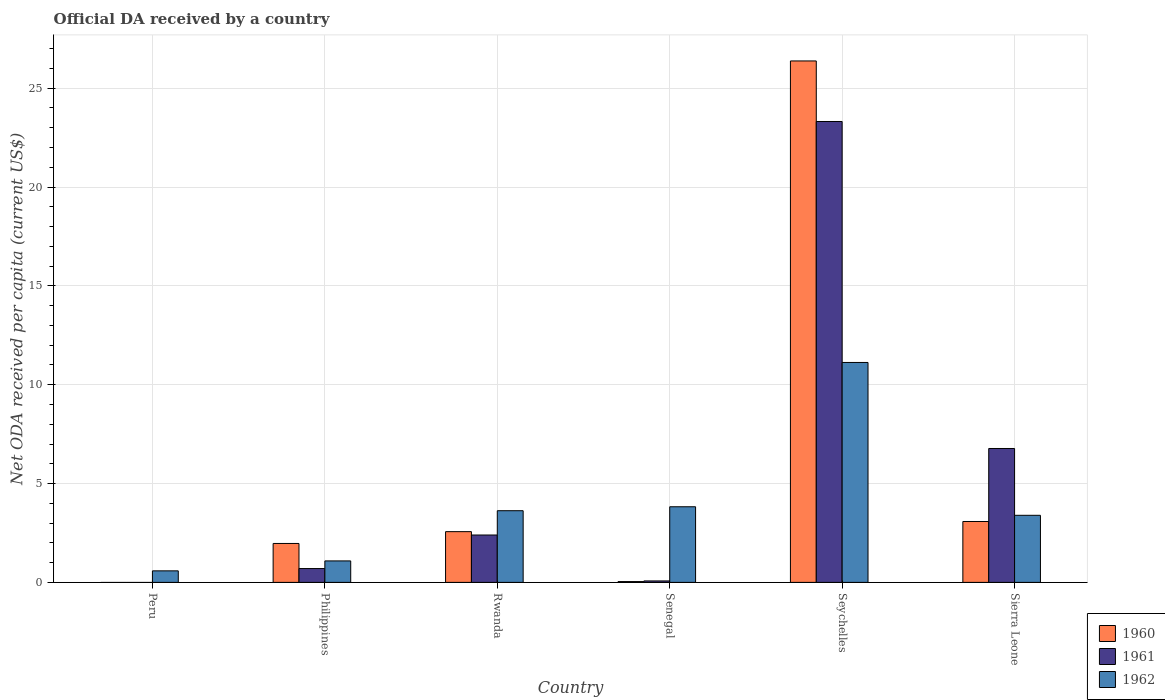Are the number of bars per tick equal to the number of legend labels?
Make the answer very short. No. In how many cases, is the number of bars for a given country not equal to the number of legend labels?
Provide a short and direct response. 1. What is the ODA received in in 1962 in Seychelles?
Your answer should be very brief. 11.13. Across all countries, what is the maximum ODA received in in 1961?
Keep it short and to the point. 23.32. Across all countries, what is the minimum ODA received in in 1960?
Provide a succinct answer. 0. In which country was the ODA received in in 1961 maximum?
Provide a succinct answer. Seychelles. What is the total ODA received in in 1961 in the graph?
Offer a very short reply. 33.26. What is the difference between the ODA received in in 1962 in Peru and that in Philippines?
Offer a very short reply. -0.5. What is the difference between the ODA received in in 1962 in Peru and the ODA received in in 1960 in Seychelles?
Your response must be concise. -25.8. What is the average ODA received in in 1960 per country?
Your answer should be compact. 5.67. What is the difference between the ODA received in of/in 1960 and ODA received in of/in 1962 in Sierra Leone?
Ensure brevity in your answer.  -0.31. What is the ratio of the ODA received in in 1962 in Seychelles to that in Sierra Leone?
Provide a succinct answer. 3.28. Is the ODA received in in 1962 in Philippines less than that in Seychelles?
Your answer should be compact. Yes. What is the difference between the highest and the second highest ODA received in in 1960?
Offer a very short reply. 23.3. What is the difference between the highest and the lowest ODA received in in 1962?
Provide a succinct answer. 10.54. Is the sum of the ODA received in in 1960 in Rwanda and Senegal greater than the maximum ODA received in in 1962 across all countries?
Your answer should be compact. No. How many countries are there in the graph?
Your answer should be very brief. 6. Are the values on the major ticks of Y-axis written in scientific E-notation?
Keep it short and to the point. No. Does the graph contain any zero values?
Offer a very short reply. Yes. What is the title of the graph?
Offer a terse response. Official DA received by a country. What is the label or title of the Y-axis?
Provide a short and direct response. Net ODA received per capita (current US$). What is the Net ODA received per capita (current US$) of 1962 in Peru?
Make the answer very short. 0.58. What is the Net ODA received per capita (current US$) of 1960 in Philippines?
Your answer should be compact. 1.97. What is the Net ODA received per capita (current US$) of 1961 in Philippines?
Offer a very short reply. 0.7. What is the Net ODA received per capita (current US$) in 1962 in Philippines?
Offer a terse response. 1.09. What is the Net ODA received per capita (current US$) of 1960 in Rwanda?
Ensure brevity in your answer.  2.57. What is the Net ODA received per capita (current US$) in 1961 in Rwanda?
Make the answer very short. 2.4. What is the Net ODA received per capita (current US$) of 1962 in Rwanda?
Your response must be concise. 3.63. What is the Net ODA received per capita (current US$) in 1960 in Senegal?
Ensure brevity in your answer.  0.04. What is the Net ODA received per capita (current US$) of 1961 in Senegal?
Your answer should be very brief. 0.07. What is the Net ODA received per capita (current US$) of 1962 in Senegal?
Your response must be concise. 3.83. What is the Net ODA received per capita (current US$) in 1960 in Seychelles?
Your response must be concise. 26.38. What is the Net ODA received per capita (current US$) in 1961 in Seychelles?
Your answer should be very brief. 23.32. What is the Net ODA received per capita (current US$) in 1962 in Seychelles?
Provide a succinct answer. 11.13. What is the Net ODA received per capita (current US$) of 1960 in Sierra Leone?
Your response must be concise. 3.08. What is the Net ODA received per capita (current US$) of 1961 in Sierra Leone?
Give a very brief answer. 6.77. What is the Net ODA received per capita (current US$) in 1962 in Sierra Leone?
Offer a terse response. 3.39. Across all countries, what is the maximum Net ODA received per capita (current US$) in 1960?
Offer a terse response. 26.38. Across all countries, what is the maximum Net ODA received per capita (current US$) in 1961?
Give a very brief answer. 23.32. Across all countries, what is the maximum Net ODA received per capita (current US$) in 1962?
Ensure brevity in your answer.  11.13. Across all countries, what is the minimum Net ODA received per capita (current US$) in 1960?
Your answer should be very brief. 0. Across all countries, what is the minimum Net ODA received per capita (current US$) in 1961?
Give a very brief answer. 0. Across all countries, what is the minimum Net ODA received per capita (current US$) of 1962?
Give a very brief answer. 0.58. What is the total Net ODA received per capita (current US$) of 1960 in the graph?
Offer a terse response. 34.04. What is the total Net ODA received per capita (current US$) in 1961 in the graph?
Offer a terse response. 33.26. What is the total Net ODA received per capita (current US$) of 1962 in the graph?
Ensure brevity in your answer.  23.64. What is the difference between the Net ODA received per capita (current US$) in 1962 in Peru and that in Philippines?
Offer a very short reply. -0.5. What is the difference between the Net ODA received per capita (current US$) in 1962 in Peru and that in Rwanda?
Make the answer very short. -3.04. What is the difference between the Net ODA received per capita (current US$) in 1962 in Peru and that in Senegal?
Make the answer very short. -3.24. What is the difference between the Net ODA received per capita (current US$) of 1962 in Peru and that in Seychelles?
Give a very brief answer. -10.54. What is the difference between the Net ODA received per capita (current US$) in 1962 in Peru and that in Sierra Leone?
Provide a succinct answer. -2.81. What is the difference between the Net ODA received per capita (current US$) of 1960 in Philippines and that in Rwanda?
Make the answer very short. -0.6. What is the difference between the Net ODA received per capita (current US$) of 1961 in Philippines and that in Rwanda?
Give a very brief answer. -1.7. What is the difference between the Net ODA received per capita (current US$) of 1962 in Philippines and that in Rwanda?
Ensure brevity in your answer.  -2.54. What is the difference between the Net ODA received per capita (current US$) in 1960 in Philippines and that in Senegal?
Your response must be concise. 1.93. What is the difference between the Net ODA received per capita (current US$) of 1961 in Philippines and that in Senegal?
Offer a very short reply. 0.63. What is the difference between the Net ODA received per capita (current US$) of 1962 in Philippines and that in Senegal?
Keep it short and to the point. -2.74. What is the difference between the Net ODA received per capita (current US$) in 1960 in Philippines and that in Seychelles?
Provide a short and direct response. -24.41. What is the difference between the Net ODA received per capita (current US$) of 1961 in Philippines and that in Seychelles?
Provide a short and direct response. -22.62. What is the difference between the Net ODA received per capita (current US$) of 1962 in Philippines and that in Seychelles?
Offer a terse response. -10.04. What is the difference between the Net ODA received per capita (current US$) of 1960 in Philippines and that in Sierra Leone?
Provide a succinct answer. -1.11. What is the difference between the Net ODA received per capita (current US$) of 1961 in Philippines and that in Sierra Leone?
Provide a succinct answer. -6.07. What is the difference between the Net ODA received per capita (current US$) in 1962 in Philippines and that in Sierra Leone?
Give a very brief answer. -2.31. What is the difference between the Net ODA received per capita (current US$) of 1960 in Rwanda and that in Senegal?
Make the answer very short. 2.53. What is the difference between the Net ODA received per capita (current US$) in 1961 in Rwanda and that in Senegal?
Ensure brevity in your answer.  2.32. What is the difference between the Net ODA received per capita (current US$) of 1960 in Rwanda and that in Seychelles?
Provide a short and direct response. -23.81. What is the difference between the Net ODA received per capita (current US$) of 1961 in Rwanda and that in Seychelles?
Your answer should be compact. -20.92. What is the difference between the Net ODA received per capita (current US$) of 1962 in Rwanda and that in Seychelles?
Give a very brief answer. -7.5. What is the difference between the Net ODA received per capita (current US$) in 1960 in Rwanda and that in Sierra Leone?
Provide a succinct answer. -0.51. What is the difference between the Net ODA received per capita (current US$) of 1961 in Rwanda and that in Sierra Leone?
Ensure brevity in your answer.  -4.38. What is the difference between the Net ODA received per capita (current US$) of 1962 in Rwanda and that in Sierra Leone?
Provide a short and direct response. 0.23. What is the difference between the Net ODA received per capita (current US$) of 1960 in Senegal and that in Seychelles?
Your answer should be compact. -26.34. What is the difference between the Net ODA received per capita (current US$) in 1961 in Senegal and that in Seychelles?
Provide a succinct answer. -23.24. What is the difference between the Net ODA received per capita (current US$) of 1962 in Senegal and that in Seychelles?
Your answer should be very brief. -7.3. What is the difference between the Net ODA received per capita (current US$) of 1960 in Senegal and that in Sierra Leone?
Offer a very short reply. -3.04. What is the difference between the Net ODA received per capita (current US$) of 1961 in Senegal and that in Sierra Leone?
Provide a succinct answer. -6.7. What is the difference between the Net ODA received per capita (current US$) in 1962 in Senegal and that in Sierra Leone?
Offer a very short reply. 0.43. What is the difference between the Net ODA received per capita (current US$) of 1960 in Seychelles and that in Sierra Leone?
Your answer should be very brief. 23.3. What is the difference between the Net ODA received per capita (current US$) in 1961 in Seychelles and that in Sierra Leone?
Make the answer very short. 16.54. What is the difference between the Net ODA received per capita (current US$) of 1962 in Seychelles and that in Sierra Leone?
Provide a succinct answer. 7.73. What is the difference between the Net ODA received per capita (current US$) of 1960 in Philippines and the Net ODA received per capita (current US$) of 1961 in Rwanda?
Offer a very short reply. -0.43. What is the difference between the Net ODA received per capita (current US$) of 1960 in Philippines and the Net ODA received per capita (current US$) of 1962 in Rwanda?
Ensure brevity in your answer.  -1.66. What is the difference between the Net ODA received per capita (current US$) of 1961 in Philippines and the Net ODA received per capita (current US$) of 1962 in Rwanda?
Ensure brevity in your answer.  -2.93. What is the difference between the Net ODA received per capita (current US$) in 1960 in Philippines and the Net ODA received per capita (current US$) in 1961 in Senegal?
Provide a succinct answer. 1.9. What is the difference between the Net ODA received per capita (current US$) of 1960 in Philippines and the Net ODA received per capita (current US$) of 1962 in Senegal?
Your answer should be very brief. -1.86. What is the difference between the Net ODA received per capita (current US$) in 1961 in Philippines and the Net ODA received per capita (current US$) in 1962 in Senegal?
Ensure brevity in your answer.  -3.13. What is the difference between the Net ODA received per capita (current US$) of 1960 in Philippines and the Net ODA received per capita (current US$) of 1961 in Seychelles?
Make the answer very short. -21.35. What is the difference between the Net ODA received per capita (current US$) in 1960 in Philippines and the Net ODA received per capita (current US$) in 1962 in Seychelles?
Keep it short and to the point. -9.16. What is the difference between the Net ODA received per capita (current US$) in 1961 in Philippines and the Net ODA received per capita (current US$) in 1962 in Seychelles?
Offer a terse response. -10.43. What is the difference between the Net ODA received per capita (current US$) in 1960 in Philippines and the Net ODA received per capita (current US$) in 1961 in Sierra Leone?
Offer a very short reply. -4.8. What is the difference between the Net ODA received per capita (current US$) in 1960 in Philippines and the Net ODA received per capita (current US$) in 1962 in Sierra Leone?
Your answer should be very brief. -1.42. What is the difference between the Net ODA received per capita (current US$) of 1961 in Philippines and the Net ODA received per capita (current US$) of 1962 in Sierra Leone?
Offer a very short reply. -2.69. What is the difference between the Net ODA received per capita (current US$) of 1960 in Rwanda and the Net ODA received per capita (current US$) of 1961 in Senegal?
Offer a terse response. 2.49. What is the difference between the Net ODA received per capita (current US$) in 1960 in Rwanda and the Net ODA received per capita (current US$) in 1962 in Senegal?
Offer a very short reply. -1.26. What is the difference between the Net ODA received per capita (current US$) in 1961 in Rwanda and the Net ODA received per capita (current US$) in 1962 in Senegal?
Provide a succinct answer. -1.43. What is the difference between the Net ODA received per capita (current US$) of 1960 in Rwanda and the Net ODA received per capita (current US$) of 1961 in Seychelles?
Ensure brevity in your answer.  -20.75. What is the difference between the Net ODA received per capita (current US$) in 1960 in Rwanda and the Net ODA received per capita (current US$) in 1962 in Seychelles?
Offer a terse response. -8.56. What is the difference between the Net ODA received per capita (current US$) of 1961 in Rwanda and the Net ODA received per capita (current US$) of 1962 in Seychelles?
Your answer should be very brief. -8.73. What is the difference between the Net ODA received per capita (current US$) of 1960 in Rwanda and the Net ODA received per capita (current US$) of 1961 in Sierra Leone?
Keep it short and to the point. -4.21. What is the difference between the Net ODA received per capita (current US$) of 1960 in Rwanda and the Net ODA received per capita (current US$) of 1962 in Sierra Leone?
Your answer should be very brief. -0.83. What is the difference between the Net ODA received per capita (current US$) in 1961 in Rwanda and the Net ODA received per capita (current US$) in 1962 in Sierra Leone?
Keep it short and to the point. -1. What is the difference between the Net ODA received per capita (current US$) in 1960 in Senegal and the Net ODA received per capita (current US$) in 1961 in Seychelles?
Your response must be concise. -23.28. What is the difference between the Net ODA received per capita (current US$) of 1960 in Senegal and the Net ODA received per capita (current US$) of 1962 in Seychelles?
Offer a terse response. -11.08. What is the difference between the Net ODA received per capita (current US$) of 1961 in Senegal and the Net ODA received per capita (current US$) of 1962 in Seychelles?
Your answer should be compact. -11.05. What is the difference between the Net ODA received per capita (current US$) of 1960 in Senegal and the Net ODA received per capita (current US$) of 1961 in Sierra Leone?
Keep it short and to the point. -6.73. What is the difference between the Net ODA received per capita (current US$) of 1960 in Senegal and the Net ODA received per capita (current US$) of 1962 in Sierra Leone?
Ensure brevity in your answer.  -3.35. What is the difference between the Net ODA received per capita (current US$) of 1961 in Senegal and the Net ODA received per capita (current US$) of 1962 in Sierra Leone?
Your answer should be very brief. -3.32. What is the difference between the Net ODA received per capita (current US$) in 1960 in Seychelles and the Net ODA received per capita (current US$) in 1961 in Sierra Leone?
Your answer should be very brief. 19.61. What is the difference between the Net ODA received per capita (current US$) in 1960 in Seychelles and the Net ODA received per capita (current US$) in 1962 in Sierra Leone?
Offer a very short reply. 22.99. What is the difference between the Net ODA received per capita (current US$) of 1961 in Seychelles and the Net ODA received per capita (current US$) of 1962 in Sierra Leone?
Offer a terse response. 19.92. What is the average Net ODA received per capita (current US$) in 1960 per country?
Your answer should be very brief. 5.67. What is the average Net ODA received per capita (current US$) of 1961 per country?
Give a very brief answer. 5.54. What is the average Net ODA received per capita (current US$) in 1962 per country?
Give a very brief answer. 3.94. What is the difference between the Net ODA received per capita (current US$) of 1960 and Net ODA received per capita (current US$) of 1961 in Philippines?
Your answer should be compact. 1.27. What is the difference between the Net ODA received per capita (current US$) of 1960 and Net ODA received per capita (current US$) of 1962 in Philippines?
Your response must be concise. 0.88. What is the difference between the Net ODA received per capita (current US$) in 1961 and Net ODA received per capita (current US$) in 1962 in Philippines?
Your answer should be very brief. -0.39. What is the difference between the Net ODA received per capita (current US$) of 1960 and Net ODA received per capita (current US$) of 1961 in Rwanda?
Ensure brevity in your answer.  0.17. What is the difference between the Net ODA received per capita (current US$) of 1960 and Net ODA received per capita (current US$) of 1962 in Rwanda?
Offer a terse response. -1.06. What is the difference between the Net ODA received per capita (current US$) of 1961 and Net ODA received per capita (current US$) of 1962 in Rwanda?
Your answer should be compact. -1.23. What is the difference between the Net ODA received per capita (current US$) of 1960 and Net ODA received per capita (current US$) of 1961 in Senegal?
Provide a short and direct response. -0.03. What is the difference between the Net ODA received per capita (current US$) of 1960 and Net ODA received per capita (current US$) of 1962 in Senegal?
Provide a succinct answer. -3.78. What is the difference between the Net ODA received per capita (current US$) in 1961 and Net ODA received per capita (current US$) in 1962 in Senegal?
Offer a terse response. -3.75. What is the difference between the Net ODA received per capita (current US$) of 1960 and Net ODA received per capita (current US$) of 1961 in Seychelles?
Provide a succinct answer. 3.06. What is the difference between the Net ODA received per capita (current US$) in 1960 and Net ODA received per capita (current US$) in 1962 in Seychelles?
Provide a short and direct response. 15.25. What is the difference between the Net ODA received per capita (current US$) of 1961 and Net ODA received per capita (current US$) of 1962 in Seychelles?
Provide a short and direct response. 12.19. What is the difference between the Net ODA received per capita (current US$) in 1960 and Net ODA received per capita (current US$) in 1961 in Sierra Leone?
Your answer should be very brief. -3.69. What is the difference between the Net ODA received per capita (current US$) in 1960 and Net ODA received per capita (current US$) in 1962 in Sierra Leone?
Offer a terse response. -0.31. What is the difference between the Net ODA received per capita (current US$) in 1961 and Net ODA received per capita (current US$) in 1962 in Sierra Leone?
Keep it short and to the point. 3.38. What is the ratio of the Net ODA received per capita (current US$) in 1962 in Peru to that in Philippines?
Make the answer very short. 0.54. What is the ratio of the Net ODA received per capita (current US$) in 1962 in Peru to that in Rwanda?
Keep it short and to the point. 0.16. What is the ratio of the Net ODA received per capita (current US$) of 1962 in Peru to that in Senegal?
Offer a terse response. 0.15. What is the ratio of the Net ODA received per capita (current US$) of 1962 in Peru to that in Seychelles?
Ensure brevity in your answer.  0.05. What is the ratio of the Net ODA received per capita (current US$) in 1962 in Peru to that in Sierra Leone?
Offer a very short reply. 0.17. What is the ratio of the Net ODA received per capita (current US$) in 1960 in Philippines to that in Rwanda?
Offer a terse response. 0.77. What is the ratio of the Net ODA received per capita (current US$) in 1961 in Philippines to that in Rwanda?
Your answer should be compact. 0.29. What is the ratio of the Net ODA received per capita (current US$) in 1962 in Philippines to that in Rwanda?
Offer a terse response. 0.3. What is the ratio of the Net ODA received per capita (current US$) in 1960 in Philippines to that in Senegal?
Provide a succinct answer. 48.13. What is the ratio of the Net ODA received per capita (current US$) in 1961 in Philippines to that in Senegal?
Your answer should be very brief. 9.52. What is the ratio of the Net ODA received per capita (current US$) in 1962 in Philippines to that in Senegal?
Offer a terse response. 0.28. What is the ratio of the Net ODA received per capita (current US$) in 1960 in Philippines to that in Seychelles?
Your answer should be very brief. 0.07. What is the ratio of the Net ODA received per capita (current US$) of 1961 in Philippines to that in Seychelles?
Offer a very short reply. 0.03. What is the ratio of the Net ODA received per capita (current US$) in 1962 in Philippines to that in Seychelles?
Offer a very short reply. 0.1. What is the ratio of the Net ODA received per capita (current US$) of 1960 in Philippines to that in Sierra Leone?
Give a very brief answer. 0.64. What is the ratio of the Net ODA received per capita (current US$) of 1961 in Philippines to that in Sierra Leone?
Keep it short and to the point. 0.1. What is the ratio of the Net ODA received per capita (current US$) of 1962 in Philippines to that in Sierra Leone?
Make the answer very short. 0.32. What is the ratio of the Net ODA received per capita (current US$) of 1960 in Rwanda to that in Senegal?
Offer a terse response. 62.74. What is the ratio of the Net ODA received per capita (current US$) in 1961 in Rwanda to that in Senegal?
Provide a succinct answer. 32.61. What is the ratio of the Net ODA received per capita (current US$) in 1962 in Rwanda to that in Senegal?
Provide a succinct answer. 0.95. What is the ratio of the Net ODA received per capita (current US$) in 1960 in Rwanda to that in Seychelles?
Provide a short and direct response. 0.1. What is the ratio of the Net ODA received per capita (current US$) in 1961 in Rwanda to that in Seychelles?
Offer a terse response. 0.1. What is the ratio of the Net ODA received per capita (current US$) in 1962 in Rwanda to that in Seychelles?
Your response must be concise. 0.33. What is the ratio of the Net ODA received per capita (current US$) of 1960 in Rwanda to that in Sierra Leone?
Give a very brief answer. 0.83. What is the ratio of the Net ODA received per capita (current US$) of 1961 in Rwanda to that in Sierra Leone?
Your answer should be compact. 0.35. What is the ratio of the Net ODA received per capita (current US$) in 1962 in Rwanda to that in Sierra Leone?
Offer a very short reply. 1.07. What is the ratio of the Net ODA received per capita (current US$) of 1960 in Senegal to that in Seychelles?
Provide a succinct answer. 0. What is the ratio of the Net ODA received per capita (current US$) in 1961 in Senegal to that in Seychelles?
Ensure brevity in your answer.  0. What is the ratio of the Net ODA received per capita (current US$) of 1962 in Senegal to that in Seychelles?
Keep it short and to the point. 0.34. What is the ratio of the Net ODA received per capita (current US$) in 1960 in Senegal to that in Sierra Leone?
Offer a terse response. 0.01. What is the ratio of the Net ODA received per capita (current US$) of 1961 in Senegal to that in Sierra Leone?
Provide a succinct answer. 0.01. What is the ratio of the Net ODA received per capita (current US$) in 1962 in Senegal to that in Sierra Leone?
Your response must be concise. 1.13. What is the ratio of the Net ODA received per capita (current US$) in 1960 in Seychelles to that in Sierra Leone?
Your response must be concise. 8.56. What is the ratio of the Net ODA received per capita (current US$) of 1961 in Seychelles to that in Sierra Leone?
Provide a short and direct response. 3.44. What is the ratio of the Net ODA received per capita (current US$) of 1962 in Seychelles to that in Sierra Leone?
Your response must be concise. 3.28. What is the difference between the highest and the second highest Net ODA received per capita (current US$) in 1960?
Ensure brevity in your answer.  23.3. What is the difference between the highest and the second highest Net ODA received per capita (current US$) of 1961?
Your answer should be compact. 16.54. What is the difference between the highest and the second highest Net ODA received per capita (current US$) in 1962?
Provide a succinct answer. 7.3. What is the difference between the highest and the lowest Net ODA received per capita (current US$) in 1960?
Your answer should be very brief. 26.38. What is the difference between the highest and the lowest Net ODA received per capita (current US$) of 1961?
Your response must be concise. 23.32. What is the difference between the highest and the lowest Net ODA received per capita (current US$) in 1962?
Keep it short and to the point. 10.54. 